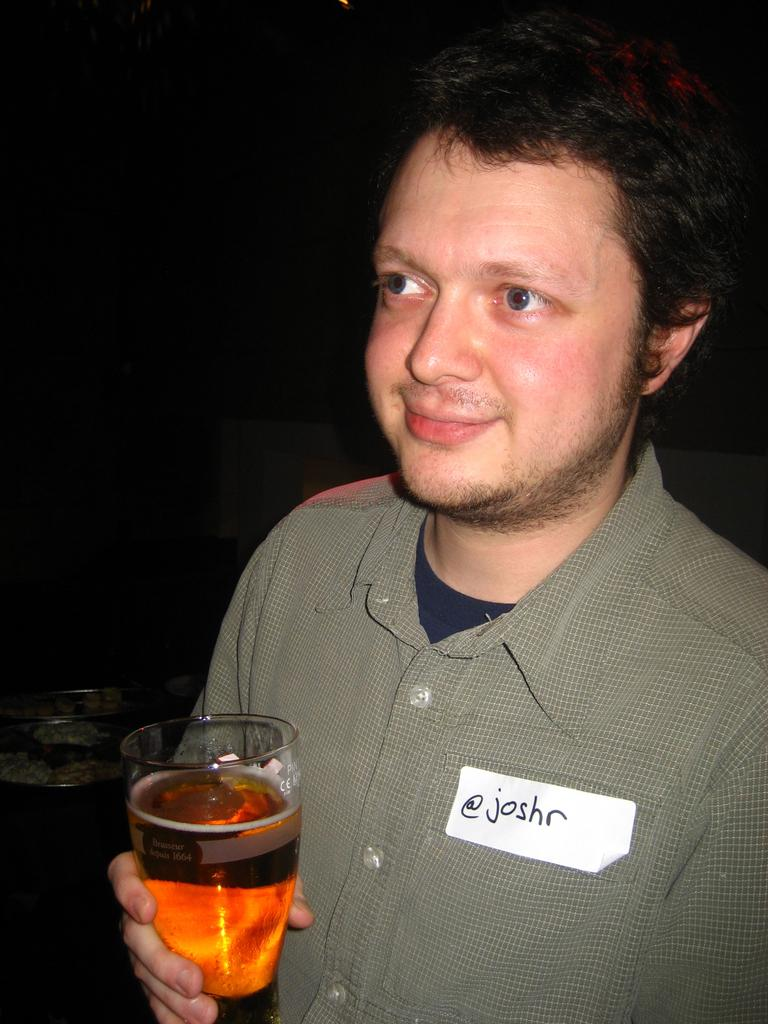What is the main subject of the image? There is a person in the image. What is the person holding in the image? The person is holding a beer glass. Can you describe any additional details about the person's appearance? The person has a tag on their shirt. What is the color of the background in the image? The background of the image is almost black in color. What type of sign can be seen in the image? There is no sign present in the image. What is the weather like in the image? The provided facts do not mention any information about the weather, so it cannot be determined from the image. 